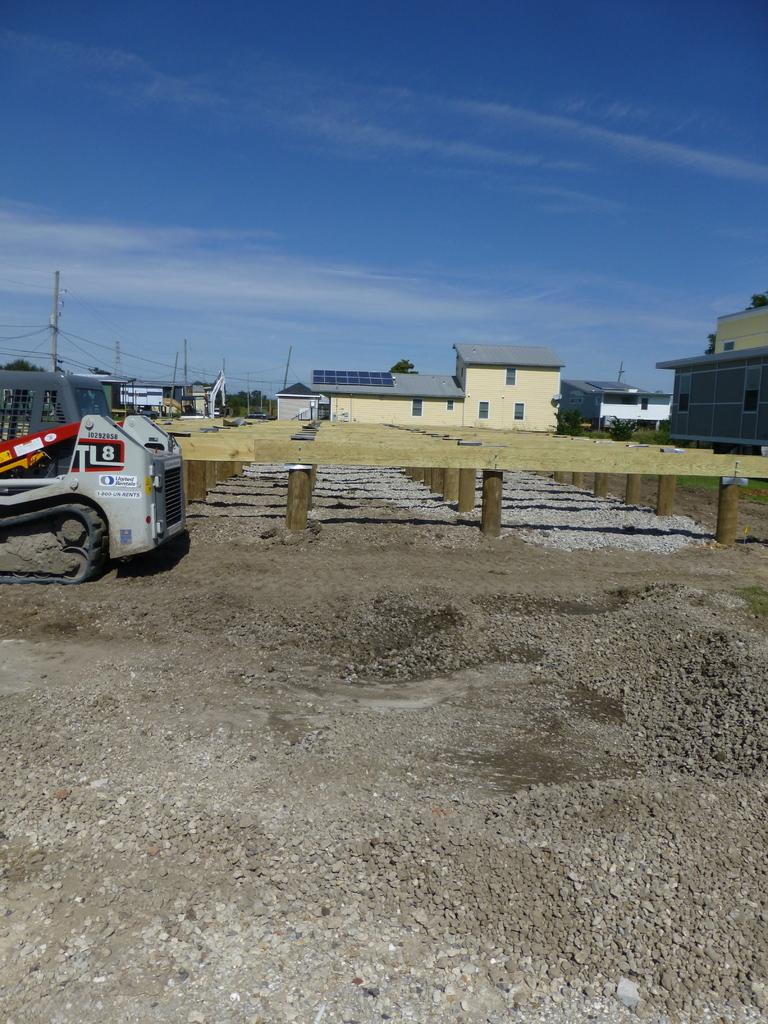What is located at the bottom of the image? There are stones at the bottom of the image. What can be seen in the background of the image? There are houses in the background of the image. Where is the vehicle positioned in the image? The vehicle is on the left side of the image. What is visible at the top of the image? The sky is visible at the top of the image. Can you tell me how many grapes are hanging from the houses in the image? There are no grapes present in the image; it features stones at the bottom and houses in the background. What type of silk is draped over the vehicle in the image? There is no silk present in the image; it features a vehicle on the left side. 